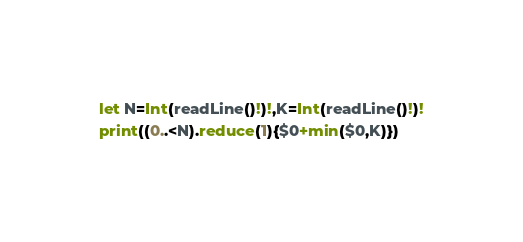<code> <loc_0><loc_0><loc_500><loc_500><_Swift_>let N=Int(readLine()!)!,K=Int(readLine()!)!
print((0..<N).reduce(1){$0+min($0,K)})
</code> 